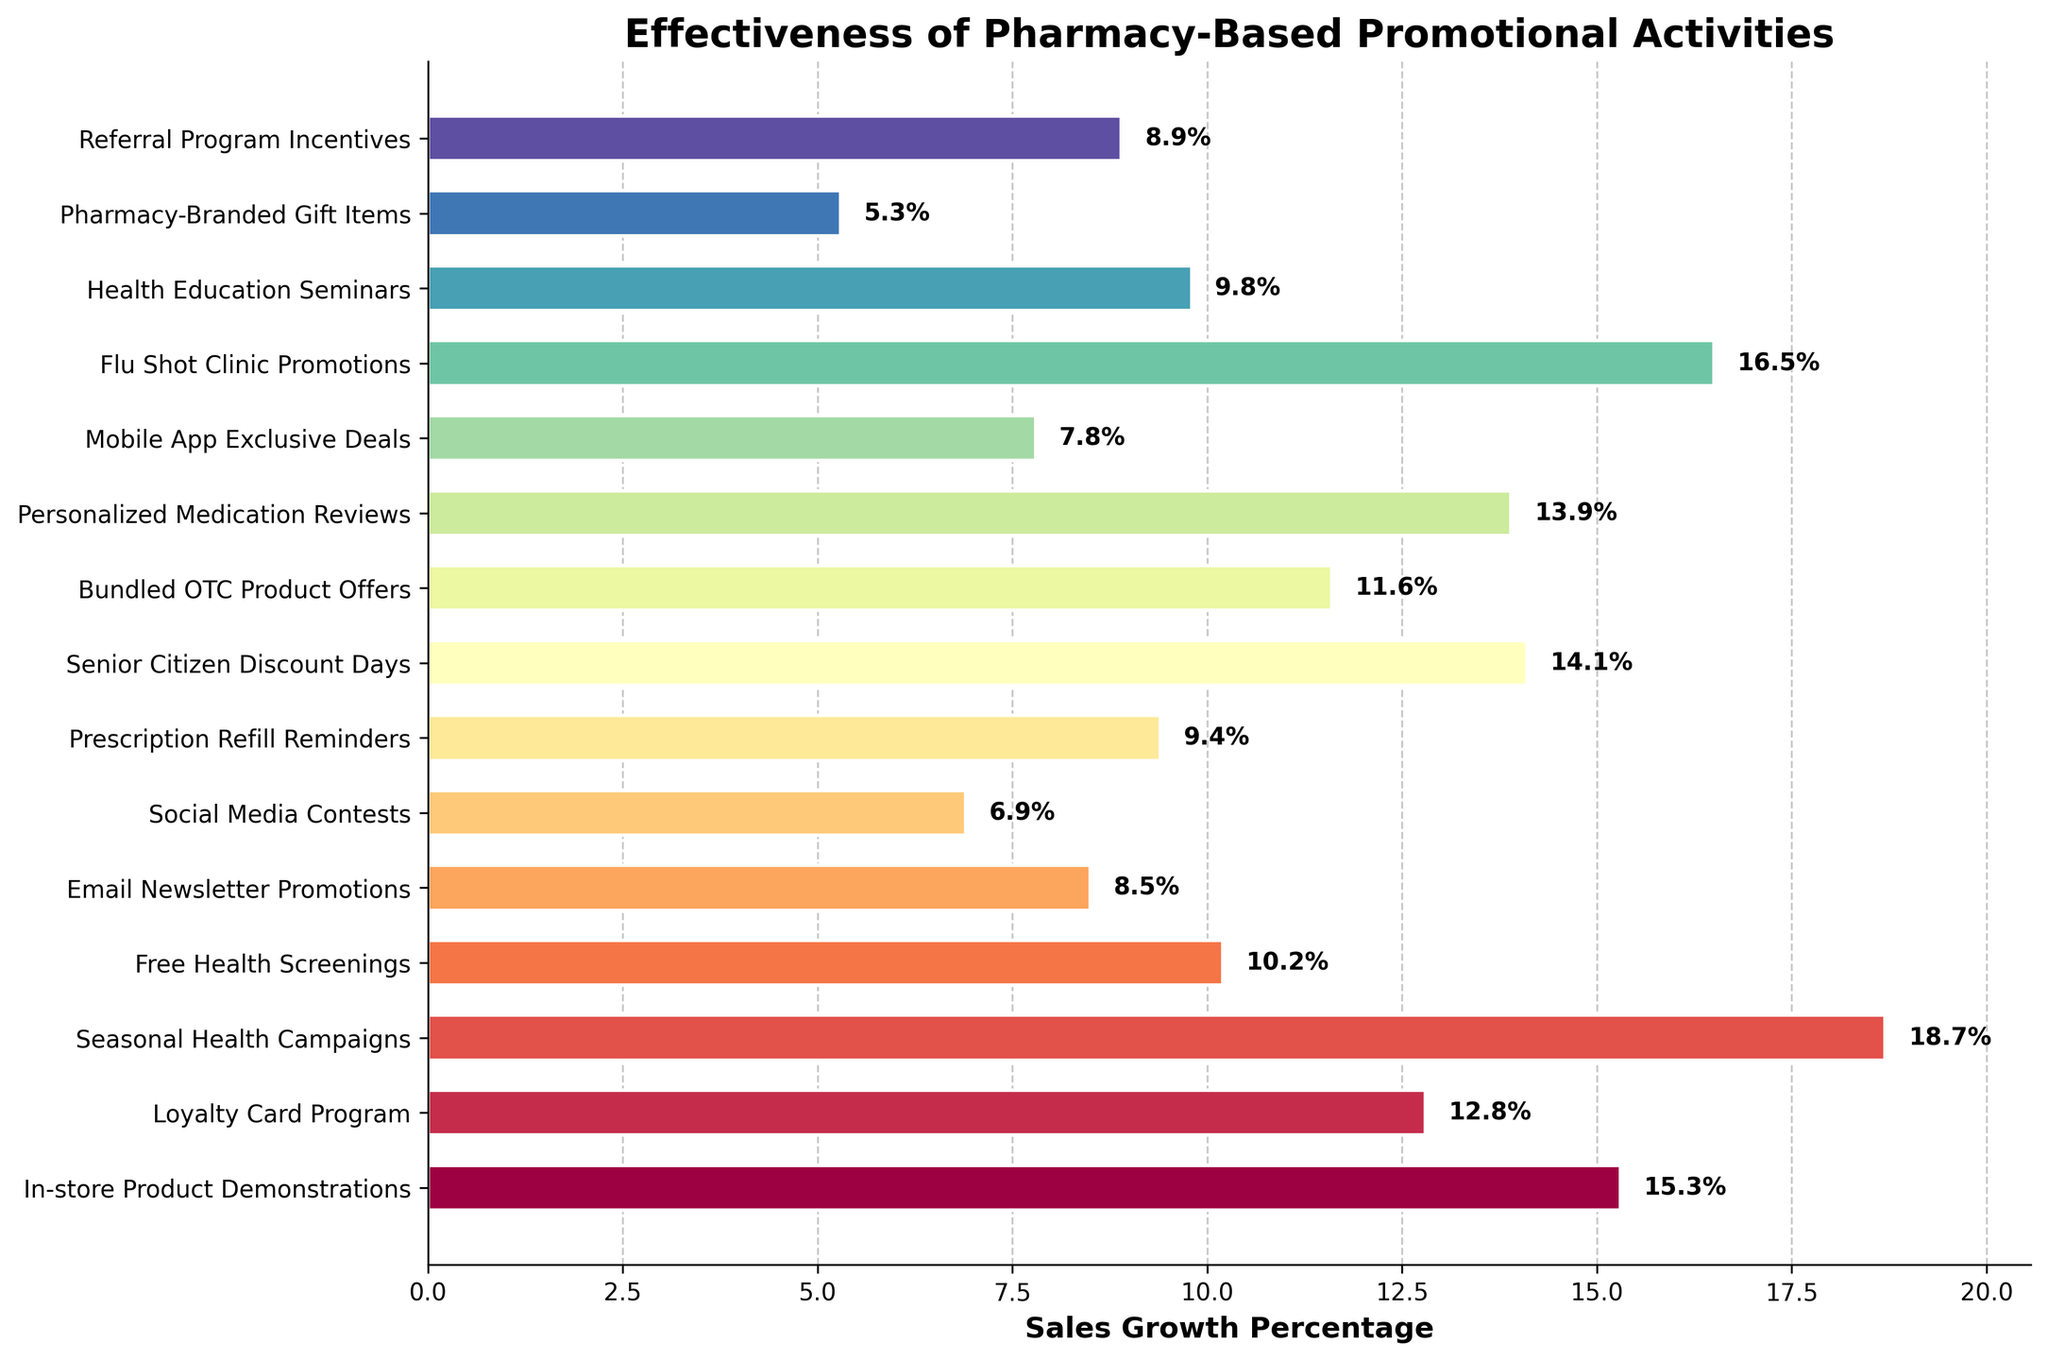Which promotional activity has the highest sales growth percentage? The promotional activity with the highest bar length and value label is "Seasonal Health Campaigns" with 18.7%.
Answer: Seasonal Health Campaigns How much higher is the sales growth percentage for Flu Shot Clinic Promotions compared to Social Media Contests? The sales growth for Flu Shot Clinic Promotions is 16.5%, and for Social Media Contests it is 6.9%. The difference is 16.5% - 6.9% = 9.6%.
Answer: 9.6% What's the average sales growth percentage for the top three promotional activities? The top three promotional activities in terms of sales growth percentage are "Seasonal Health Campaigns" (18.7%), "Flu Shot Clinic Promotions" (16.5%), and "In-store Product Demonstrations" (15.3%). Their average is (18.7 + 16.5 + 15.3) / 3 = 16.83%.
Answer: 16.83% Which promotional activity has the lowest sales growth percentage and what is that percentage? The promotional activity with the lowest bar length and value label is "Pharmacy-Branded Gift Items" with 5.3%.
Answer: Pharmacy-Branded Gift Items, 5.3% Are there more promotional activities with sales growth percentages above or below 10%? Counting the activities with sales growth above 10%: In-store Product Demonstrations (15.3%), Loyalty Card Program (12.8%), Seasonal Health Campaigns (18.7%), Senior Citizen Discount Days (14.1%), Personalized Medication Reviews (13.9%), Bundled OTC Product Offers (11.6%), and Flu Shot Clinic Promotions (16.5%). There are 7 activities above 10%. Below 10%: Free Health Screenings (10.2%), Email Newsletter Promotions (8.5%), Social Media Contests (6.9%), Prescription Refill Reminders (9.4%), Health Education Seminars (9.8%), Mobile App Exclusive Deals (7.8%), Pharmacy-Branded Gift Items (5.3%), and Referral Program Incentives (8.9%). There are 8 activities below 10%.
Answer: Below 10% What is the combined sales growth percentage for the promotional activities that offer discounts or savings (Senior Citizen Discount Days, Loyalty Card Program, and Bundled OTC Product Offers)? Summing the percentages of "Senior Citizen Discount Days" (14.1%), "Loyalty Card Program" (12.8%), and "Bundled OTC Product Offers" (11.6%) gives 14.1% + 12.8% + 11.6% = 38.5%.
Answer: 38.5% Which two promotional activities have the closest sales growth percentages and what is the difference between them? The two closest in percentage are "Health Education Seminars" (9.8%) and "Prescription Refill Reminders" (9.4%). The difference is 9.8% - 9.4% = 0.4%.
Answer: Health Education Seminars and Prescription Refill Reminders, 0.4% Do personalized promotional activities (e.g., Personalized Medication Reviews) have higher or lower sales growth compared to group activities (e.g., Seasonal Health Campaigns)? "Seasonal Health Campaigns" has a sales growth of 18.7%, while "Personalized Medication Reviews" has a growth of 13.9%. Personalized Medication Reviews have lower sales growth compared to the group activity, Seasonal Health Campaigns.
Answer: Lower 